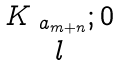Convert formula to latex. <formula><loc_0><loc_0><loc_500><loc_500>\begin{matrix} K _ { \ a _ { m + n } } ; 0 \\ l \end{matrix}</formula> 